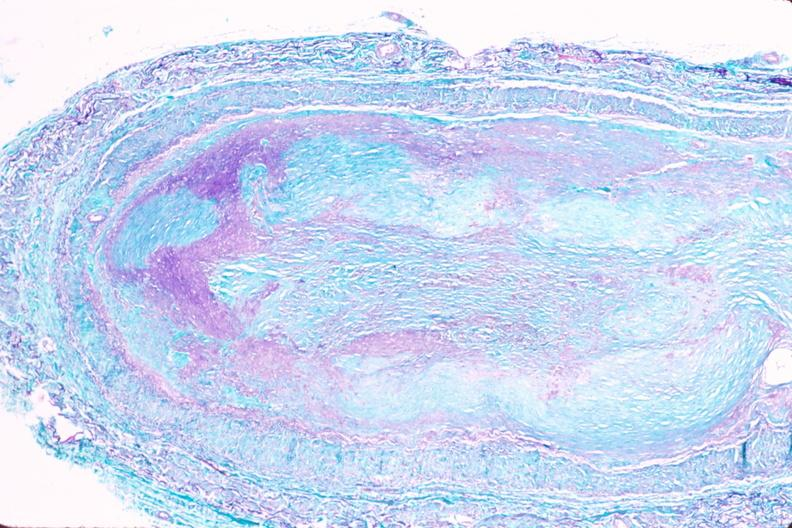does granulomata slide show saphenous vein graft sclerosis?
Answer the question using a single word or phrase. No 